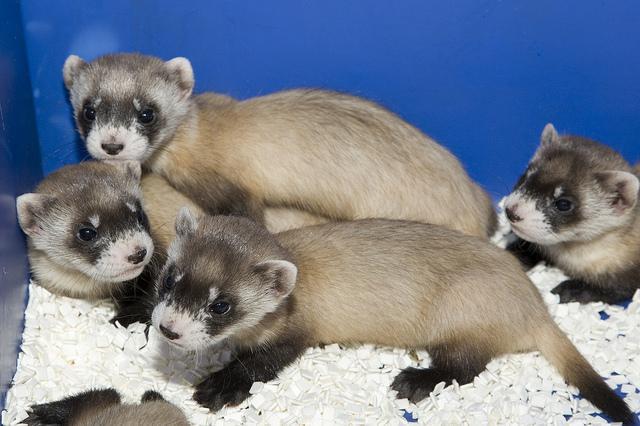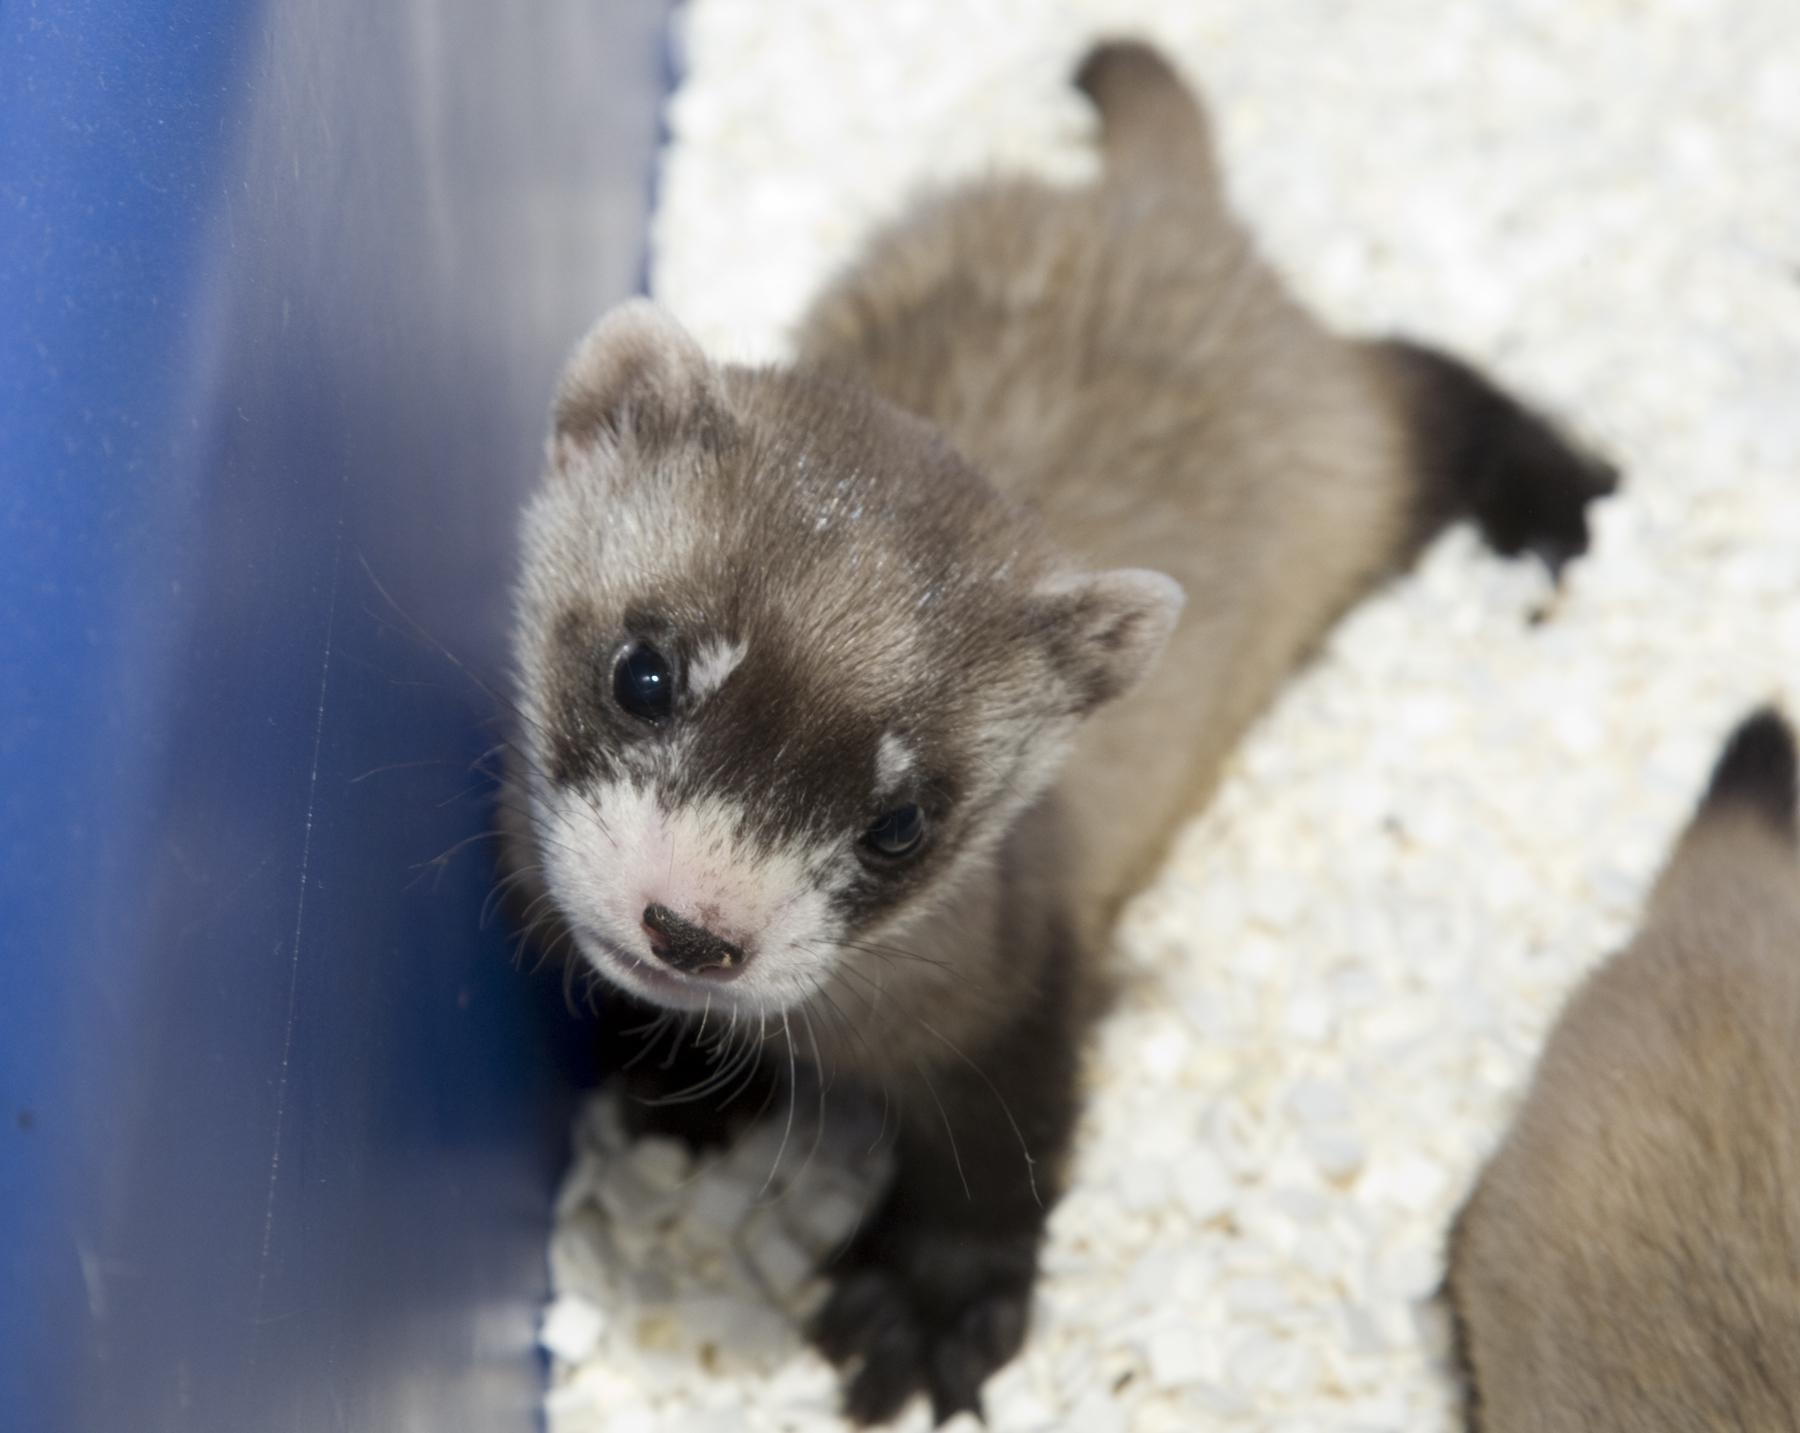The first image is the image on the left, the second image is the image on the right. For the images shown, is this caption "The left image contains at least two ferrets." true? Answer yes or no. Yes. The first image is the image on the left, the second image is the image on the right. Given the left and right images, does the statement "At one image shows a group of at least three ferrets inside a brightly colored blue box with white nesting material." hold true? Answer yes or no. Yes. 